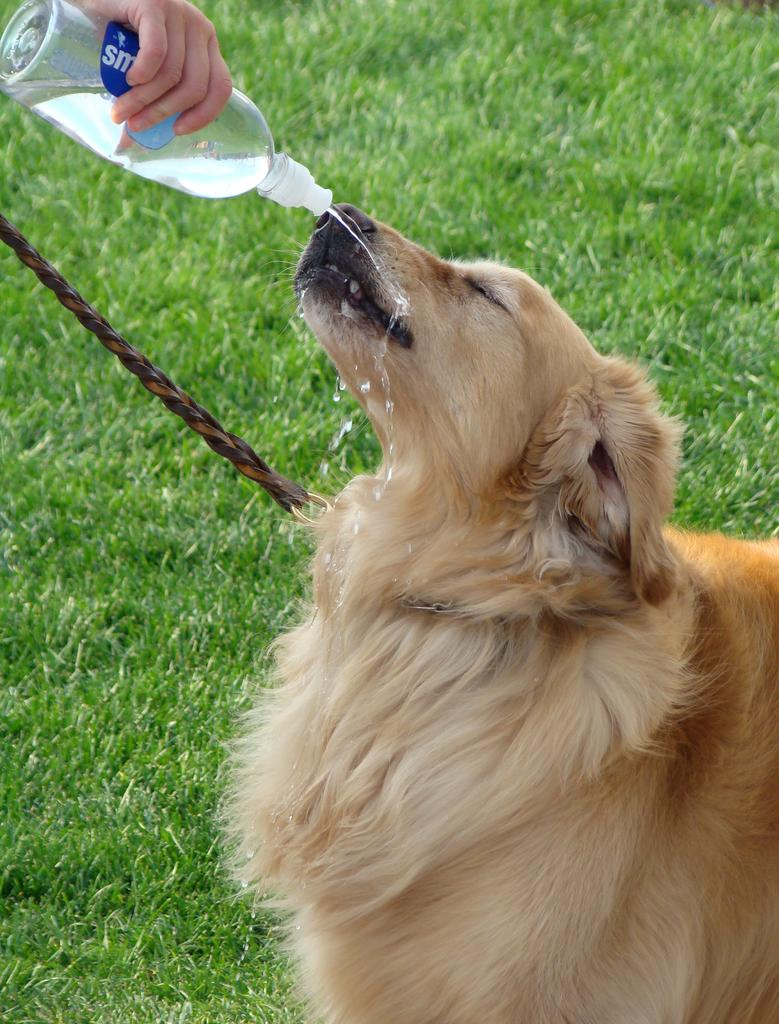What type of animal is present in the image? There is a dog in the image. What other living being can be seen in the image? There is a person in the image. What object is the person holding? The person is holding a water bottle. What type of waves can be seen in the image? There are no waves present in the image. What type of boot is the dog wearing in the image? The dog is not wearing any boots in the image. 